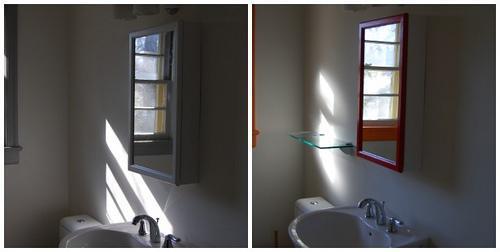How many sinks are visible?
Give a very brief answer. 2. How many dogs are there in the image?
Give a very brief answer. 0. 